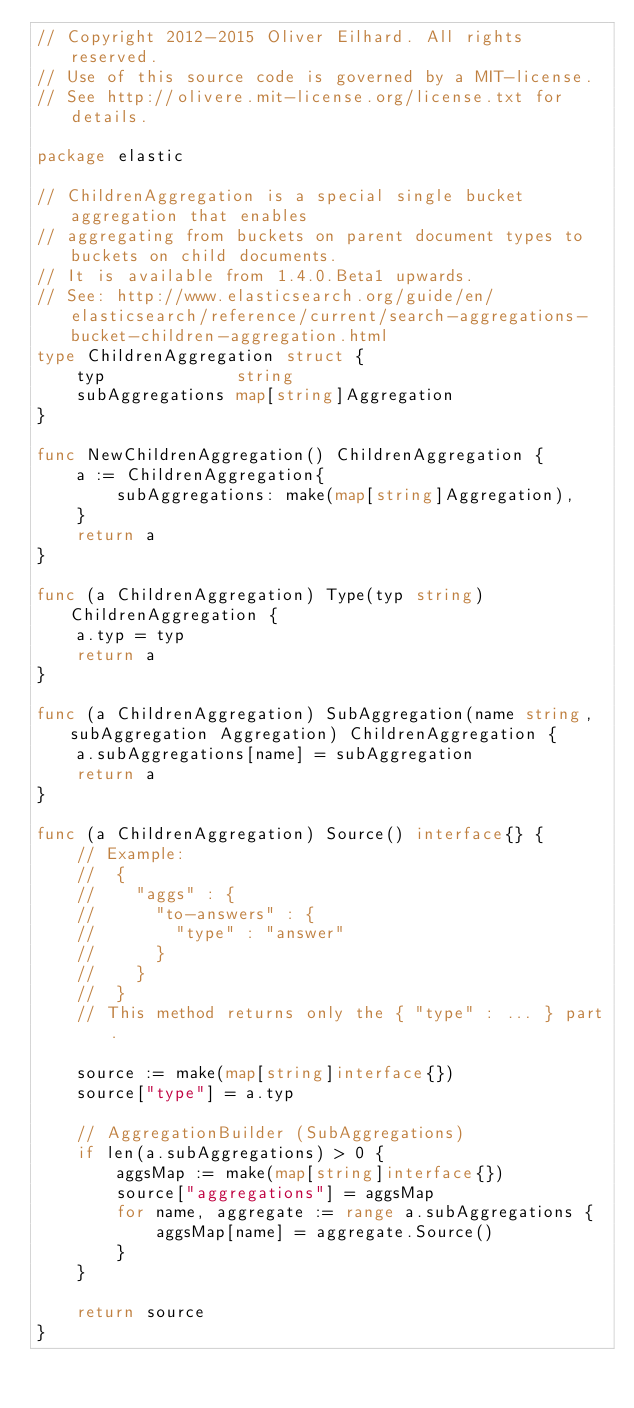Convert code to text. <code><loc_0><loc_0><loc_500><loc_500><_Go_>// Copyright 2012-2015 Oliver Eilhard. All rights reserved.
// Use of this source code is governed by a MIT-license.
// See http://olivere.mit-license.org/license.txt for details.

package elastic

// ChildrenAggregation is a special single bucket aggregation that enables
// aggregating from buckets on parent document types to buckets on child documents.
// It is available from 1.4.0.Beta1 upwards.
// See: http://www.elasticsearch.org/guide/en/elasticsearch/reference/current/search-aggregations-bucket-children-aggregation.html
type ChildrenAggregation struct {
    typ             string
    subAggregations map[string]Aggregation
}

func NewChildrenAggregation() ChildrenAggregation {
    a := ChildrenAggregation{
        subAggregations: make(map[string]Aggregation),
    }
    return a
}

func (a ChildrenAggregation) Type(typ string) ChildrenAggregation {
    a.typ = typ
    return a
}

func (a ChildrenAggregation) SubAggregation(name string, subAggregation Aggregation) ChildrenAggregation {
    a.subAggregations[name] = subAggregation
    return a
}

func (a ChildrenAggregation) Source() interface{} {
    // Example:
    //	{
    //    "aggs" : {
    //      "to-answers" : {
    //        "type" : "answer"
    //      }
    //    }
    //	}
    // This method returns only the { "type" : ... } part.

    source := make(map[string]interface{})
    source["type"] = a.typ

    // AggregationBuilder (SubAggregations)
    if len(a.subAggregations) > 0 {
        aggsMap := make(map[string]interface{})
        source["aggregations"] = aggsMap
        for name, aggregate := range a.subAggregations {
            aggsMap[name] = aggregate.Source()
        }
    }

    return source
}
</code> 